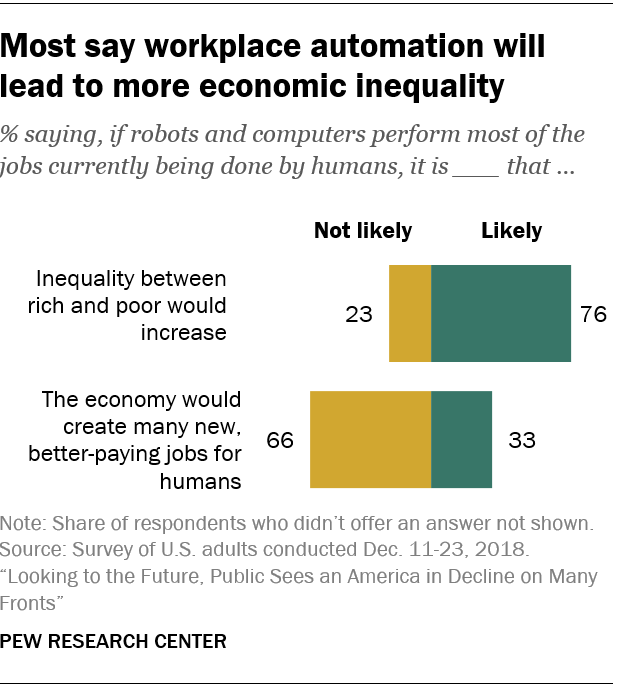Highlight a few significant elements in this photo. The category with the largest gap between choosing "likely" and "not likely" is inequality between rich and poor, which would increase if the option "not likely" is chosen. According to a survey, 76% of people believe that the inequality between rich and poor is likely to increase in the future. 